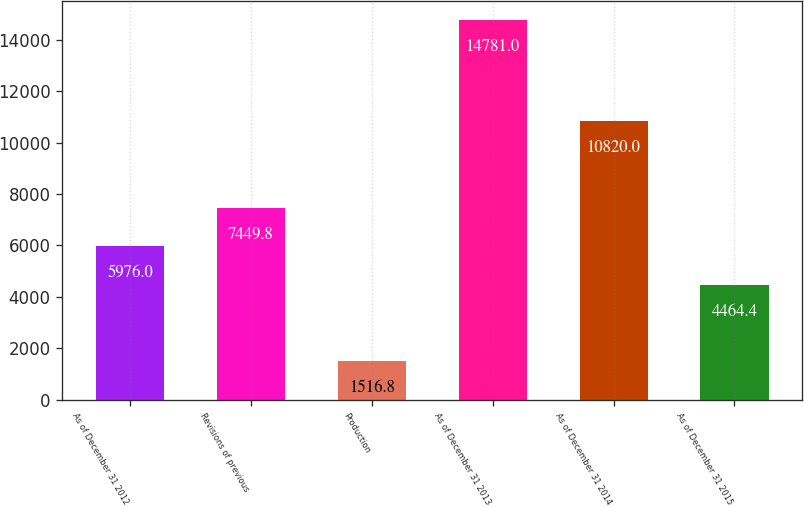<chart> <loc_0><loc_0><loc_500><loc_500><bar_chart><fcel>As of December 31 2012<fcel>Revisions of previous<fcel>Production<fcel>As of December 31 2013<fcel>As of December 31 2014<fcel>As of December 31 2015<nl><fcel>5976<fcel>7449.8<fcel>1516.8<fcel>14781<fcel>10820<fcel>4464.4<nl></chart> 